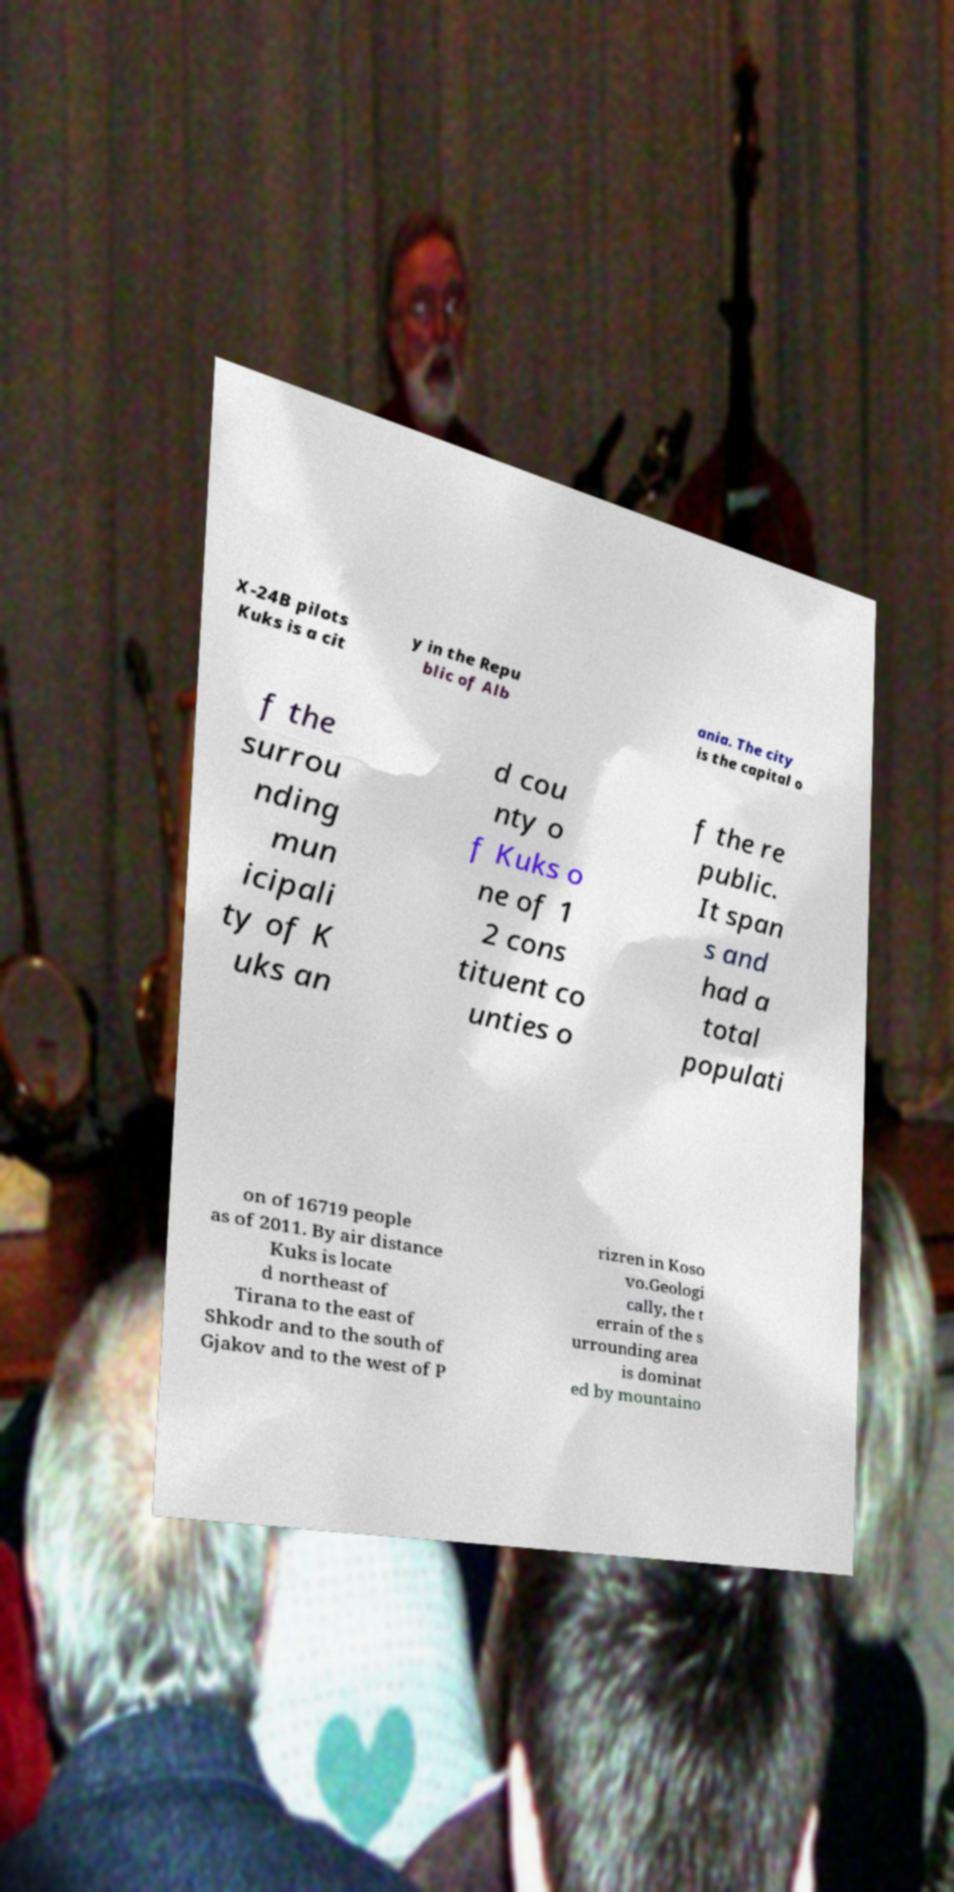What messages or text are displayed in this image? I need them in a readable, typed format. X-24B pilots Kuks is a cit y in the Repu blic of Alb ania. The city is the capital o f the surrou nding mun icipali ty of K uks an d cou nty o f Kuks o ne of 1 2 cons tituent co unties o f the re public. It span s and had a total populati on of 16719 people as of 2011. By air distance Kuks is locate d northeast of Tirana to the east of Shkodr and to the south of Gjakov and to the west of P rizren in Koso vo.Geologi cally, the t errain of the s urrounding area is dominat ed by mountaino 